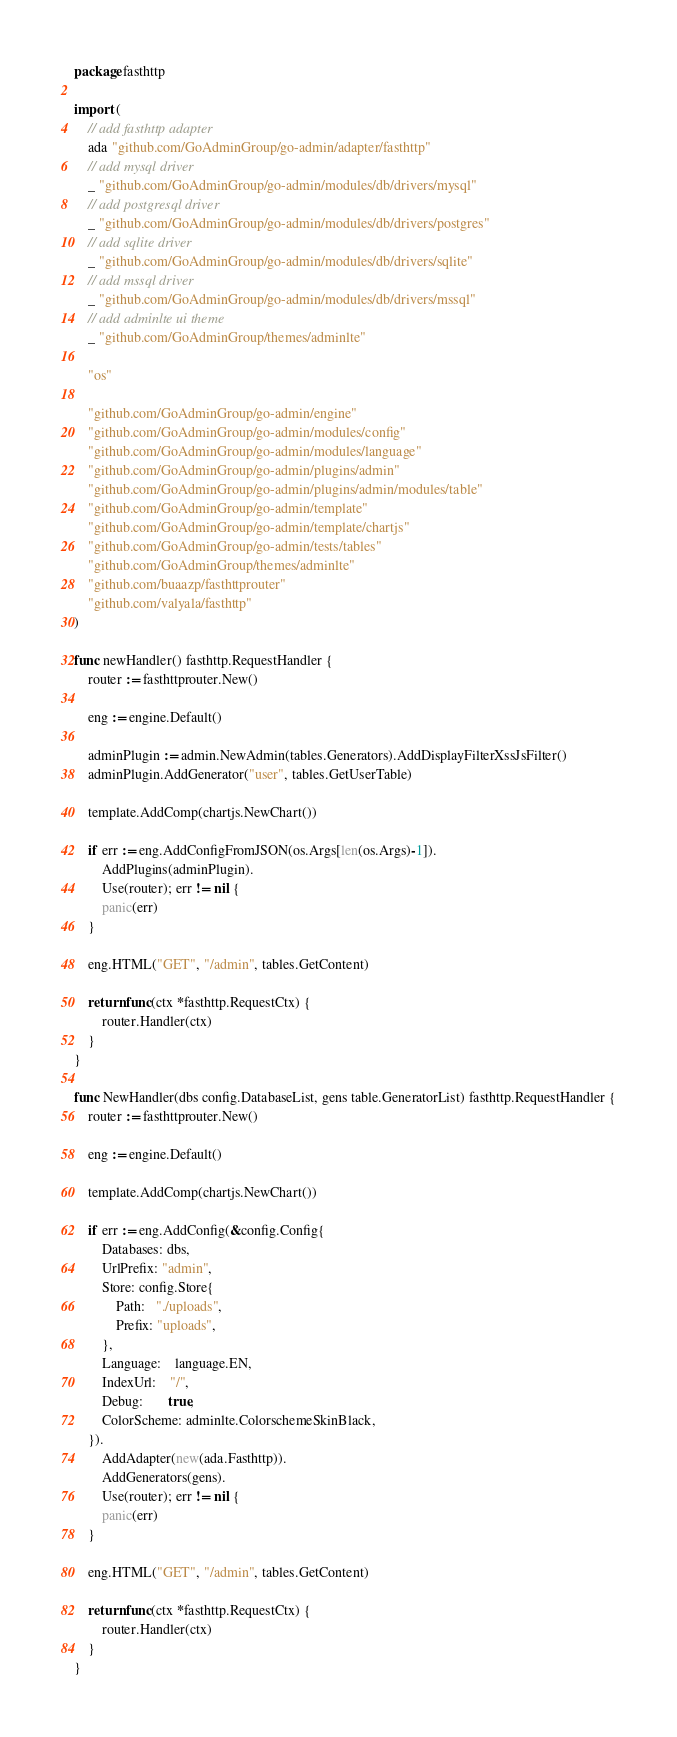Convert code to text. <code><loc_0><loc_0><loc_500><loc_500><_Go_>package fasthttp

import (
	// add fasthttp adapter
	ada "github.com/GoAdminGroup/go-admin/adapter/fasthttp"
	// add mysql driver
	_ "github.com/GoAdminGroup/go-admin/modules/db/drivers/mysql"
	// add postgresql driver
	_ "github.com/GoAdminGroup/go-admin/modules/db/drivers/postgres"
	// add sqlite driver
	_ "github.com/GoAdminGroup/go-admin/modules/db/drivers/sqlite"
	// add mssql driver
	_ "github.com/GoAdminGroup/go-admin/modules/db/drivers/mssql"
	// add adminlte ui theme
	_ "github.com/GoAdminGroup/themes/adminlte"

	"os"

	"github.com/GoAdminGroup/go-admin/engine"
	"github.com/GoAdminGroup/go-admin/modules/config"
	"github.com/GoAdminGroup/go-admin/modules/language"
	"github.com/GoAdminGroup/go-admin/plugins/admin"
	"github.com/GoAdminGroup/go-admin/plugins/admin/modules/table"
	"github.com/GoAdminGroup/go-admin/template"
	"github.com/GoAdminGroup/go-admin/template/chartjs"
	"github.com/GoAdminGroup/go-admin/tests/tables"
	"github.com/GoAdminGroup/themes/adminlte"
	"github.com/buaazp/fasthttprouter"
	"github.com/valyala/fasthttp"
)

func newHandler() fasthttp.RequestHandler {
	router := fasthttprouter.New()

	eng := engine.Default()

	adminPlugin := admin.NewAdmin(tables.Generators).AddDisplayFilterXssJsFilter()
	adminPlugin.AddGenerator("user", tables.GetUserTable)

	template.AddComp(chartjs.NewChart())

	if err := eng.AddConfigFromJSON(os.Args[len(os.Args)-1]).
		AddPlugins(adminPlugin).
		Use(router); err != nil {
		panic(err)
	}

	eng.HTML("GET", "/admin", tables.GetContent)

	return func(ctx *fasthttp.RequestCtx) {
		router.Handler(ctx)
	}
}

func NewHandler(dbs config.DatabaseList, gens table.GeneratorList) fasthttp.RequestHandler {
	router := fasthttprouter.New()

	eng := engine.Default()

	template.AddComp(chartjs.NewChart())

	if err := eng.AddConfig(&config.Config{
		Databases: dbs,
		UrlPrefix: "admin",
		Store: config.Store{
			Path:   "./uploads",
			Prefix: "uploads",
		},
		Language:    language.EN,
		IndexUrl:    "/",
		Debug:       true,
		ColorScheme: adminlte.ColorschemeSkinBlack,
	}).
		AddAdapter(new(ada.Fasthttp)).
		AddGenerators(gens).
		Use(router); err != nil {
		panic(err)
	}

	eng.HTML("GET", "/admin", tables.GetContent)

	return func(ctx *fasthttp.RequestCtx) {
		router.Handler(ctx)
	}
}
</code> 